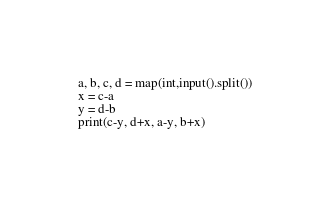<code> <loc_0><loc_0><loc_500><loc_500><_Python_>a, b, c, d = map(int,input().split())
x = c-a
y = d-b
print(c-y, d+x, a-y, b+x)</code> 